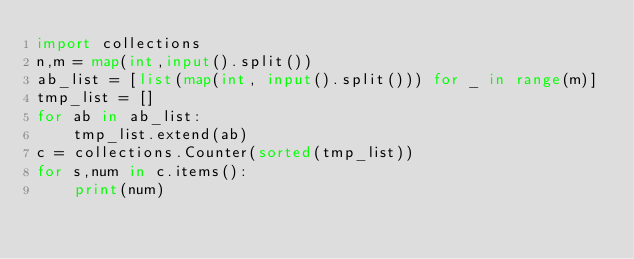<code> <loc_0><loc_0><loc_500><loc_500><_Python_>import collections
n,m = map(int,input().split())
ab_list = [list(map(int, input().split())) for _ in range(m)]
tmp_list = []
for ab in ab_list:
    tmp_list.extend(ab)
c = collections.Counter(sorted(tmp_list))
for s,num in c.items():
    print(num)</code> 